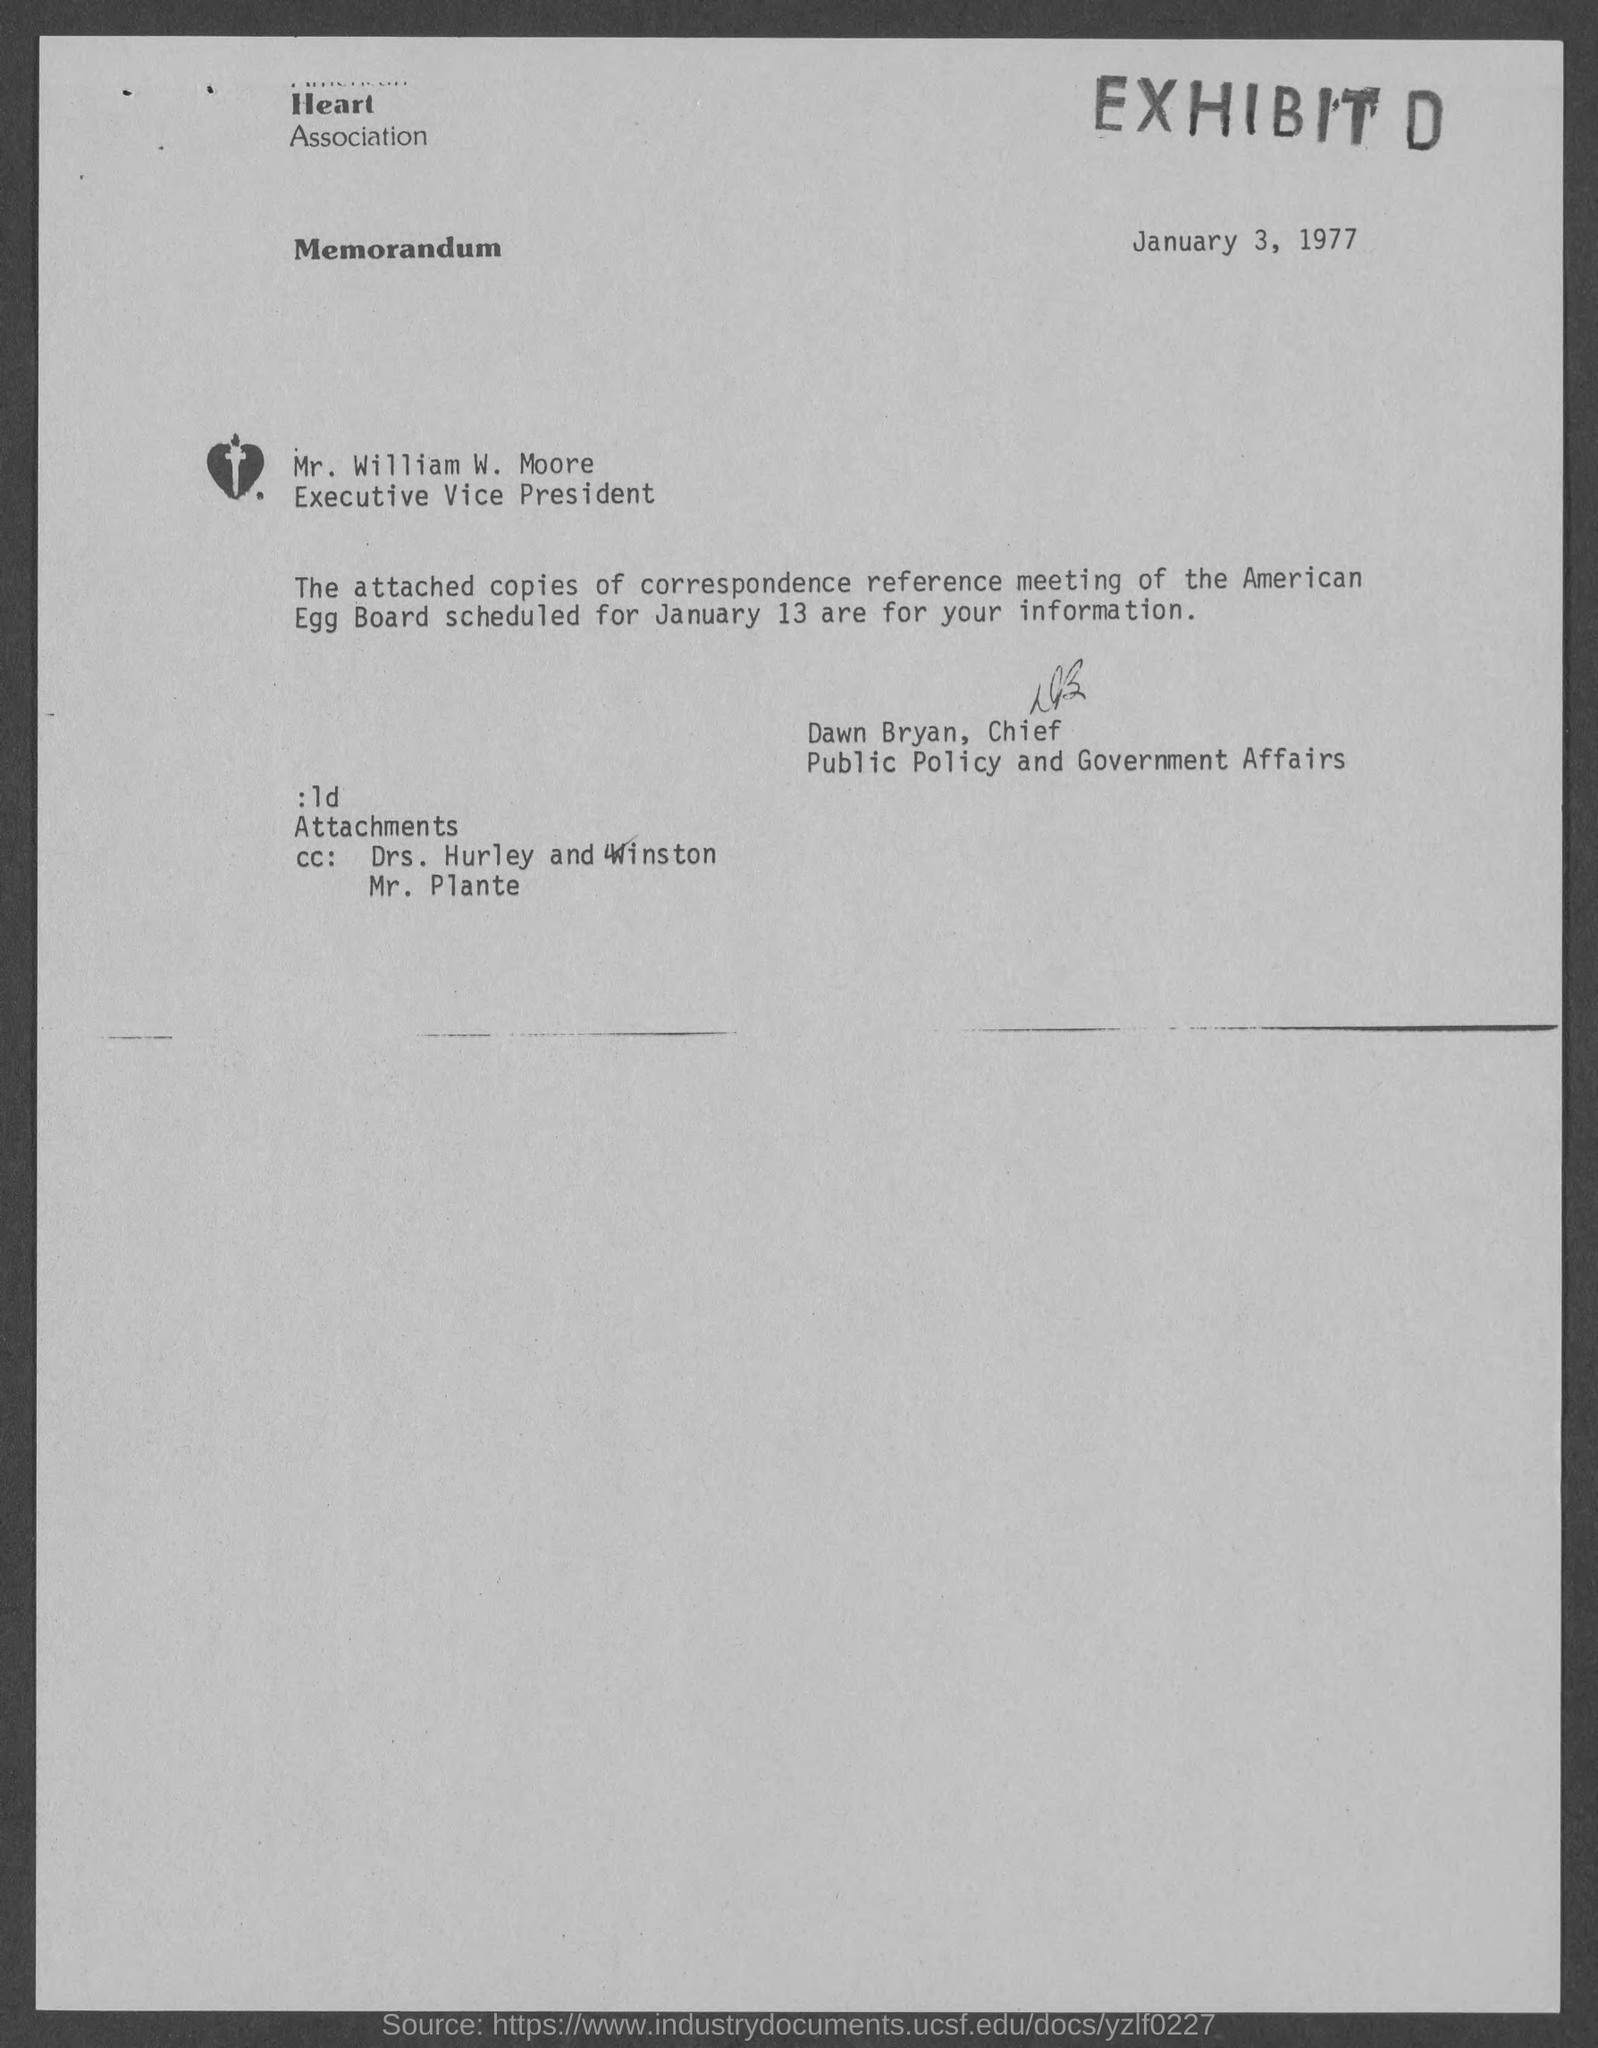Identify some key points in this picture. The date of the document is January 3, 1977. The sender of the letter is Dawn Bryan, the Chief. The reference meeting is scheduled for January 13th. 